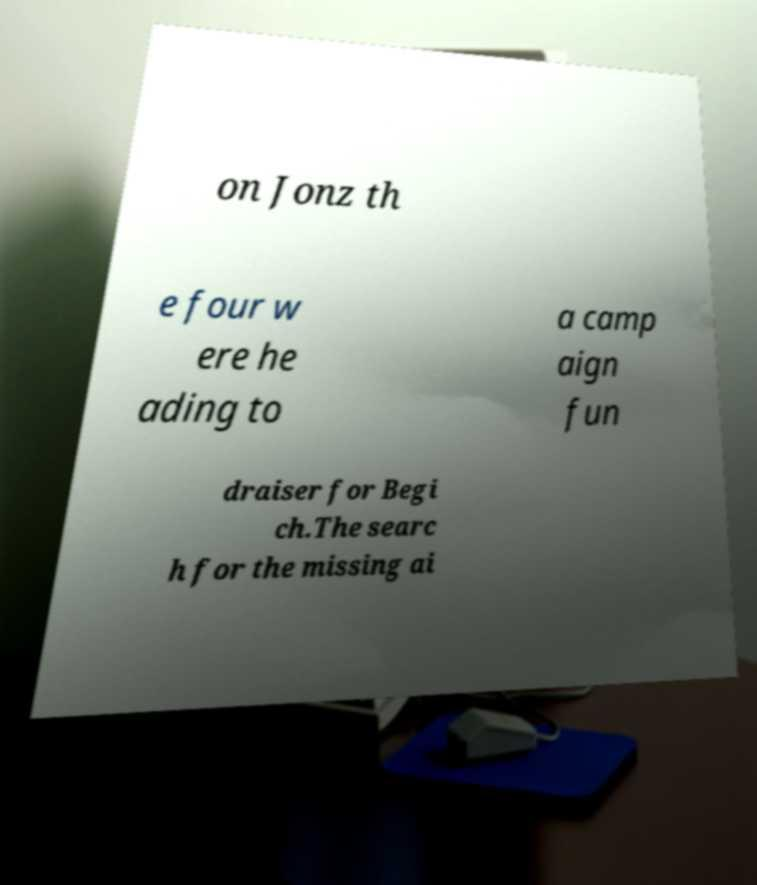Could you assist in decoding the text presented in this image and type it out clearly? on Jonz th e four w ere he ading to a camp aign fun draiser for Begi ch.The searc h for the missing ai 